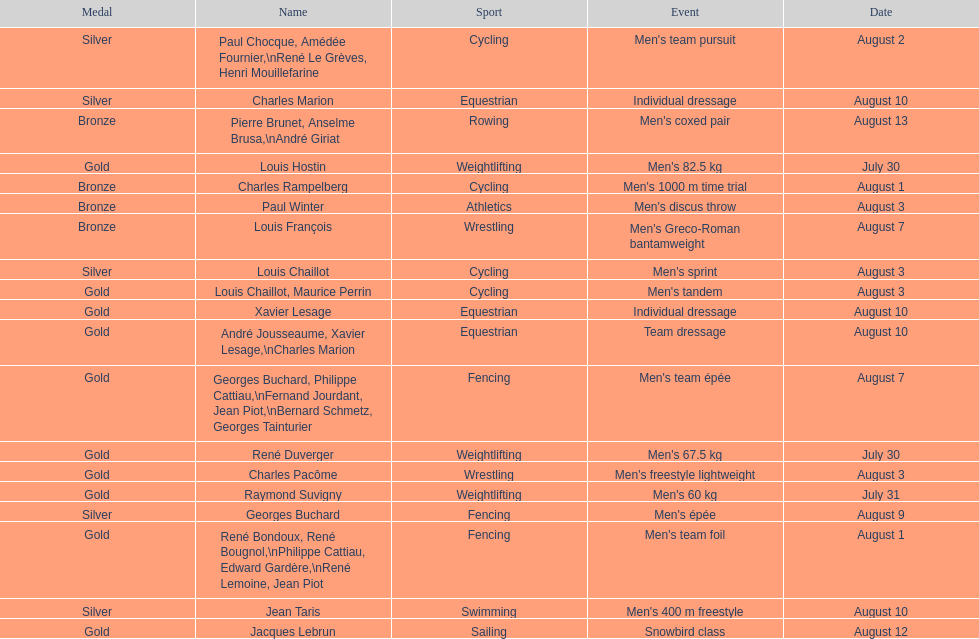Louis chaillot won a gold medal for cycling and a silver medal for what sport? Cycling. 